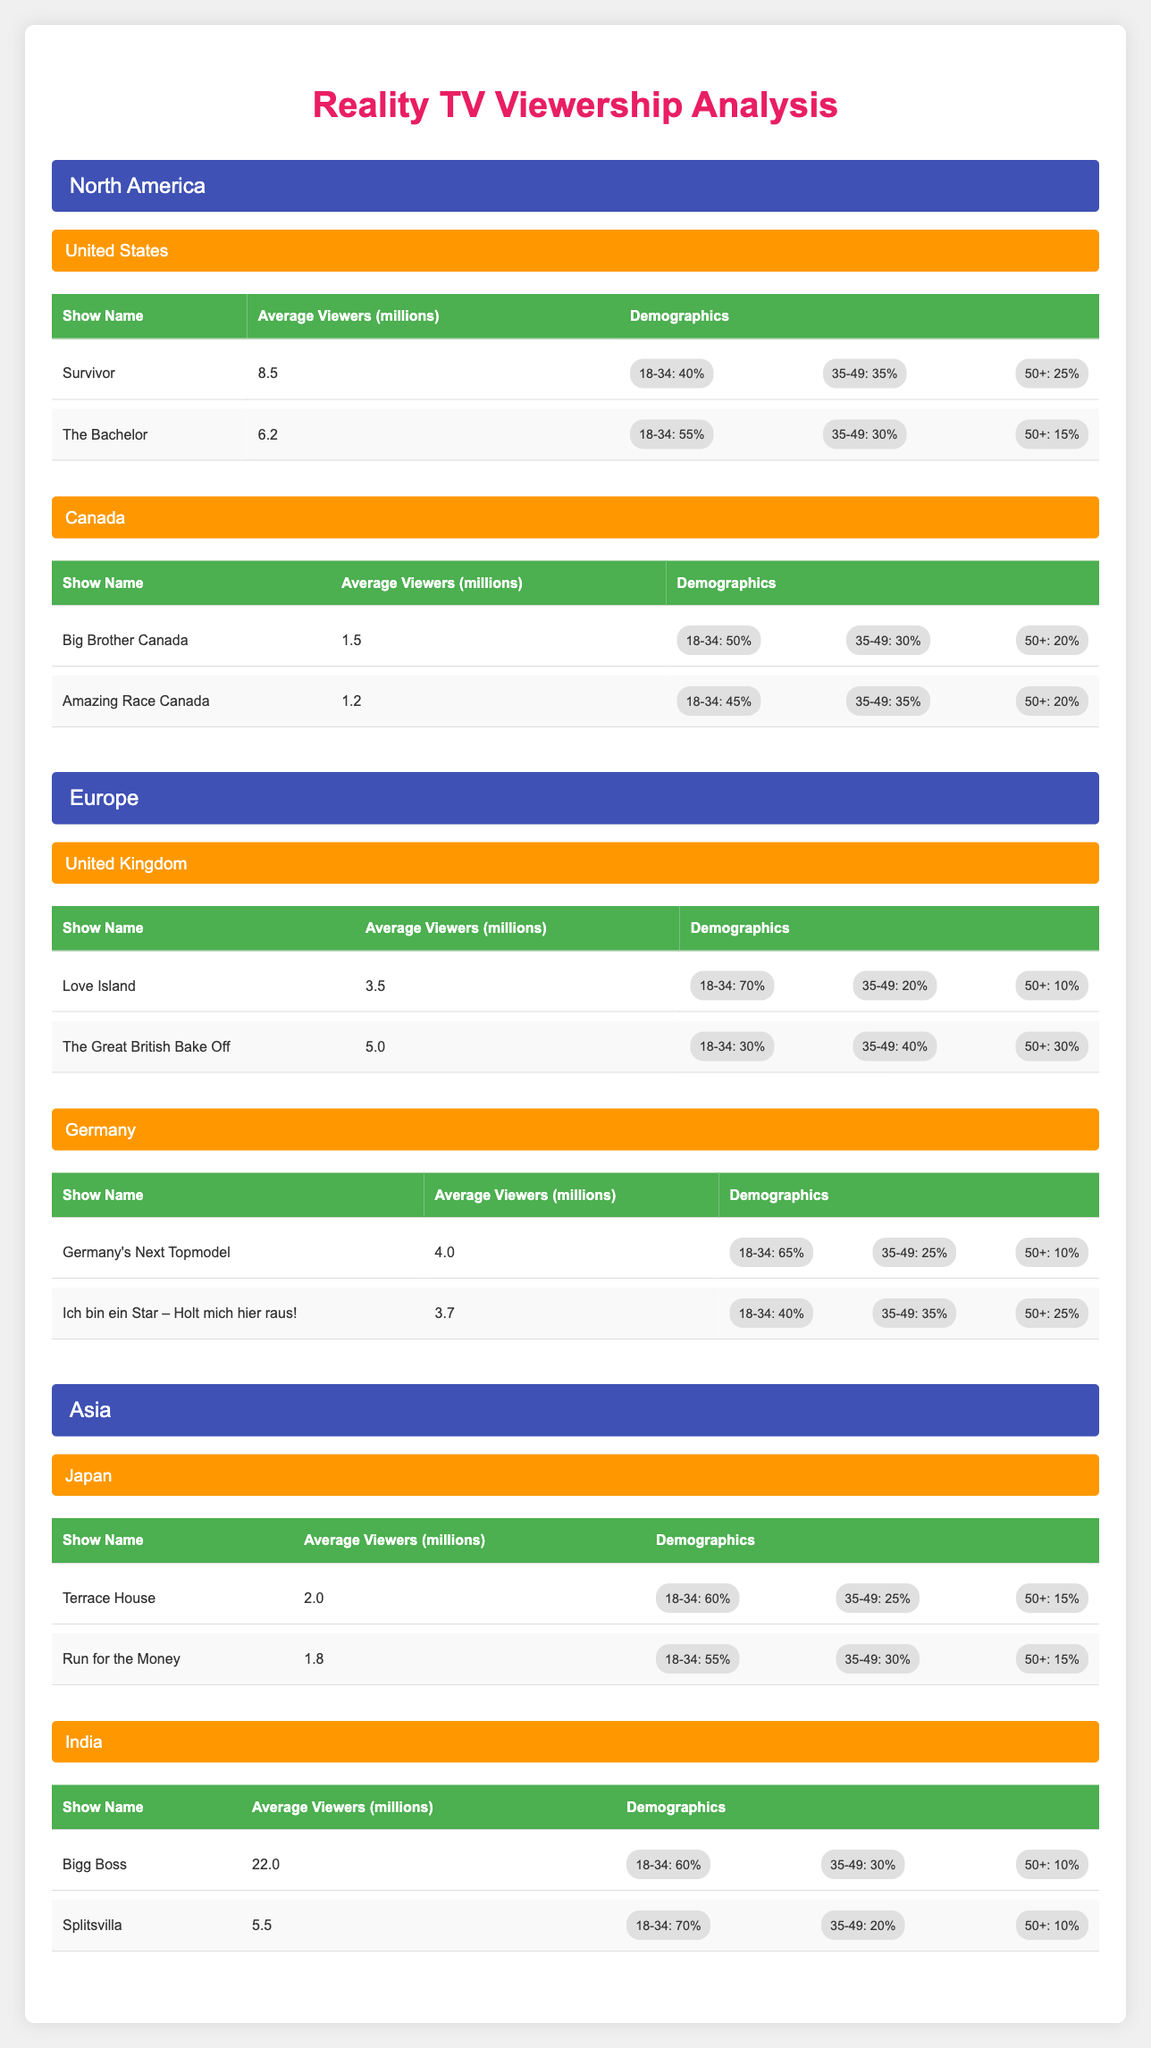What is the average number of viewers for 'Bigg Boss' in India? The average number of viewers for 'Bigg Boss' is given directly in the table. It states that the average viewers are 22.0 million.
Answer: 22.0 million Which demographic has the highest percentage of viewership for 'Love Island' in the United Kingdom? Referring to the demographics for 'Love Island', which shows that 70% of the viewers are in the 18-34 age group, which is the highest percentage among the demographic age groups listed.
Answer: 18-34 age group In which country does 'Survivor' have the highest average viewership among all listed shows? By comparing the average viewers for 'Survivor' (8.5 million in the United States) with other top shows in different countries, we see that no other show exceeds this value, making 'Survivor' the show with the highest average viewership.
Answer: United States What is the combined average viewership of the top two shows in Canada? The average viewers of the top two shows in Canada are 'Big Brother Canada' (1.5 million) and 'Amazing Race Canada' (1.2 million). Adding these figures gives us 1.5 + 1.2 = 2.7 million.
Answer: 2.7 million Is it true that 'Germany's Next Topmodel' has more viewers than 'Germany is Next Topmodel'? By comparing the average viewers, 'Germany's Next Topmodel' has 4.0 million while 'Ich bin ein Star – Holt mich hier raus!' has 3.7 million. Therefore, it's true that 'Germany's Next Topmodel' has more viewers.
Answer: Yes Which show has the least average viewers among the top-rated shows in Asia? In Asia, 'Run for the Money' has the lowest average viewers at 1.8 million, compared to 'Terrace House' with 2.0 million. Therefore, 'Run for the Money' has the least average viewers.
Answer: Run for the Money If we look at the age demographics for 'Bigg Boss' in India, what percentage of viewers is aged 50 and older? The demographics for 'Bigg Boss' indicate that 10% of the viewers are aged 50 and older, which can be referenced directly from the table.
Answer: 10% What is the percentage difference in viewership between the oldest age group (50+) for 'The Bachelor' and 'Love Island'? For 'The Bachelor', the percentage of viewers aged 50+ is 15% and for 'Love Island', it is 10%. The difference is 15% - 10% = 5%.
Answer: 5% 